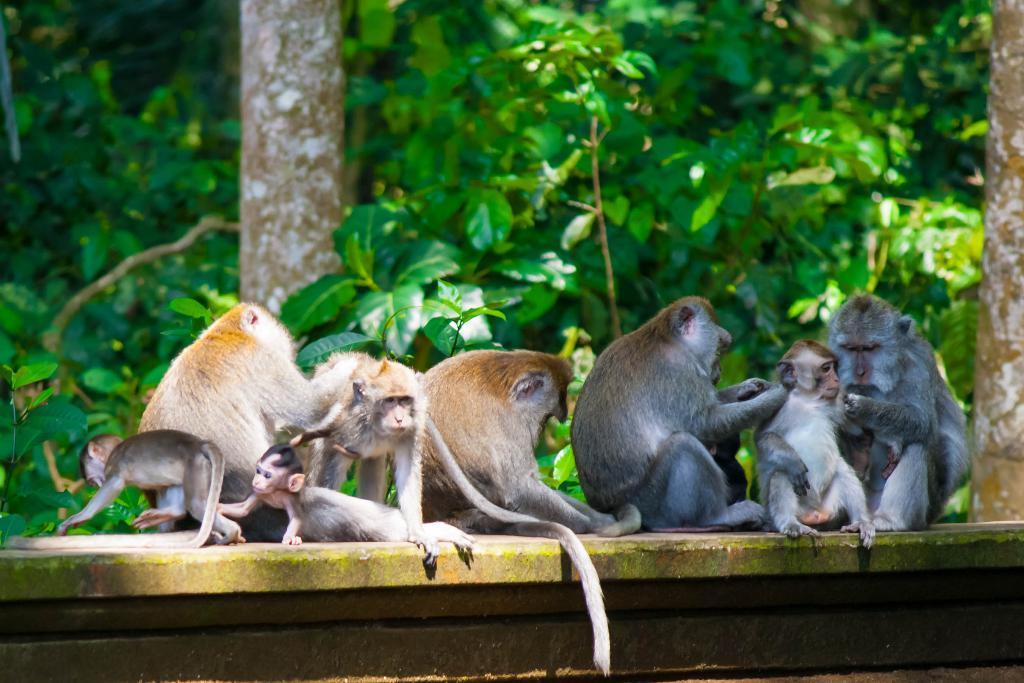Could you give a brief overview of what you see in this image? In this image we can see a group of monkeys sitting on the wall. In the background we can see trees. 